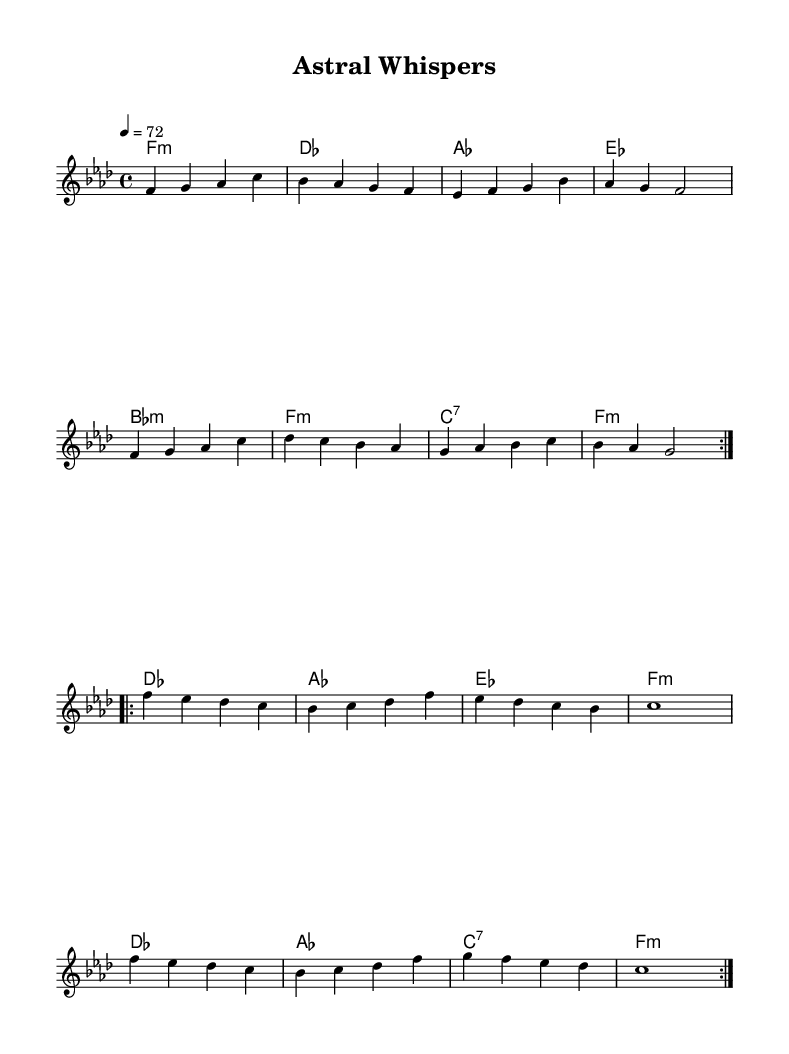What is the key signature of this music? The key signature shown is F minor, which has four flats (B♭, E♭, A♭, and D♭). This can be identified by looking at the key signature at the beginning of the staff.
Answer: F minor What is the time signature of this piece? The time signature displayed is 4/4, indicated at the beginning of the sheet music. This means there are four beats in each measure and the quarter note gets one beat.
Answer: 4/4 What is the tempo marking given in the music? The tempo marking shows "4 = 72," which indicates that the quarter note should be played at a speed of 72 beats per minute. This can be found at the top of the score.
Answer: 72 How many measures are repeated in the melody? The melody contains two sections that are repeated, each of which is labeled with "volta" indicating that these measures are to be played twice.
Answer: 2 What is the quality of the first chord in the harmonies? The first chord is labeled as "f1:m," which indicates it is F minor. The "m" denotes a minor quality of the chord. This determination is made by looking at the chord names written below the measures.
Answer: F minor Which note lasts for an entire measure in the second section of the melody? The note "c" in the second section is held for a full measure, indicated by its notation as "c1," meaning it is a whole note. This can be seen in the repeating second section of the melody.
Answer: c How many different chords are used in the harmonies section? The chord section lists a total of eight distinct chords, each indicated by their respective names below the melody, showing varied musical progressions throughout the piece.
Answer: 8 